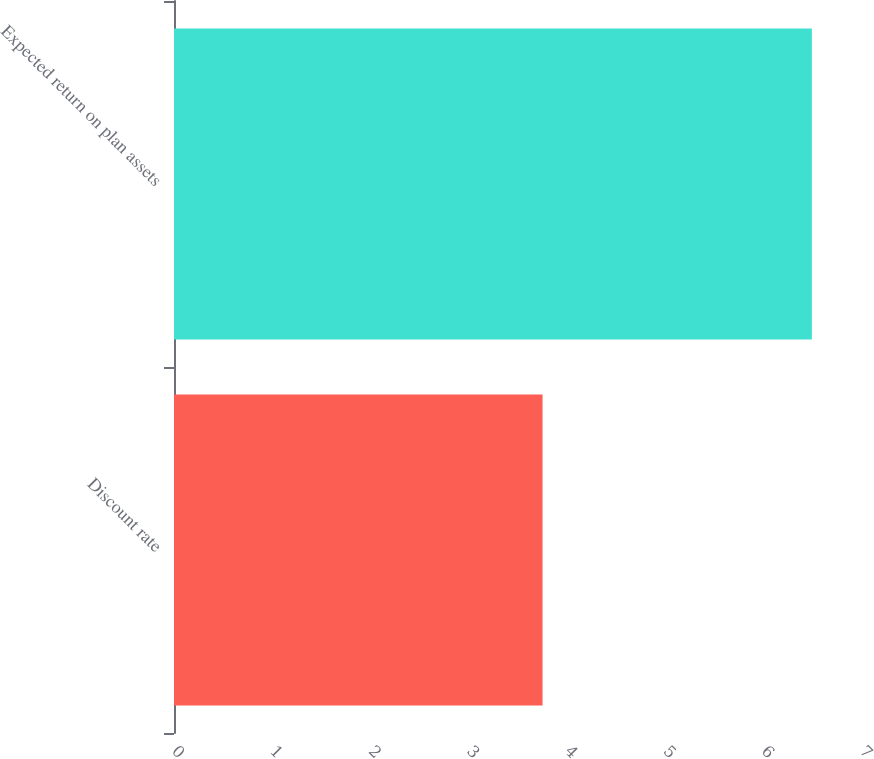Convert chart to OTSL. <chart><loc_0><loc_0><loc_500><loc_500><bar_chart><fcel>Discount rate<fcel>Expected return on plan assets<nl><fcel>3.75<fcel>6.49<nl></chart> 